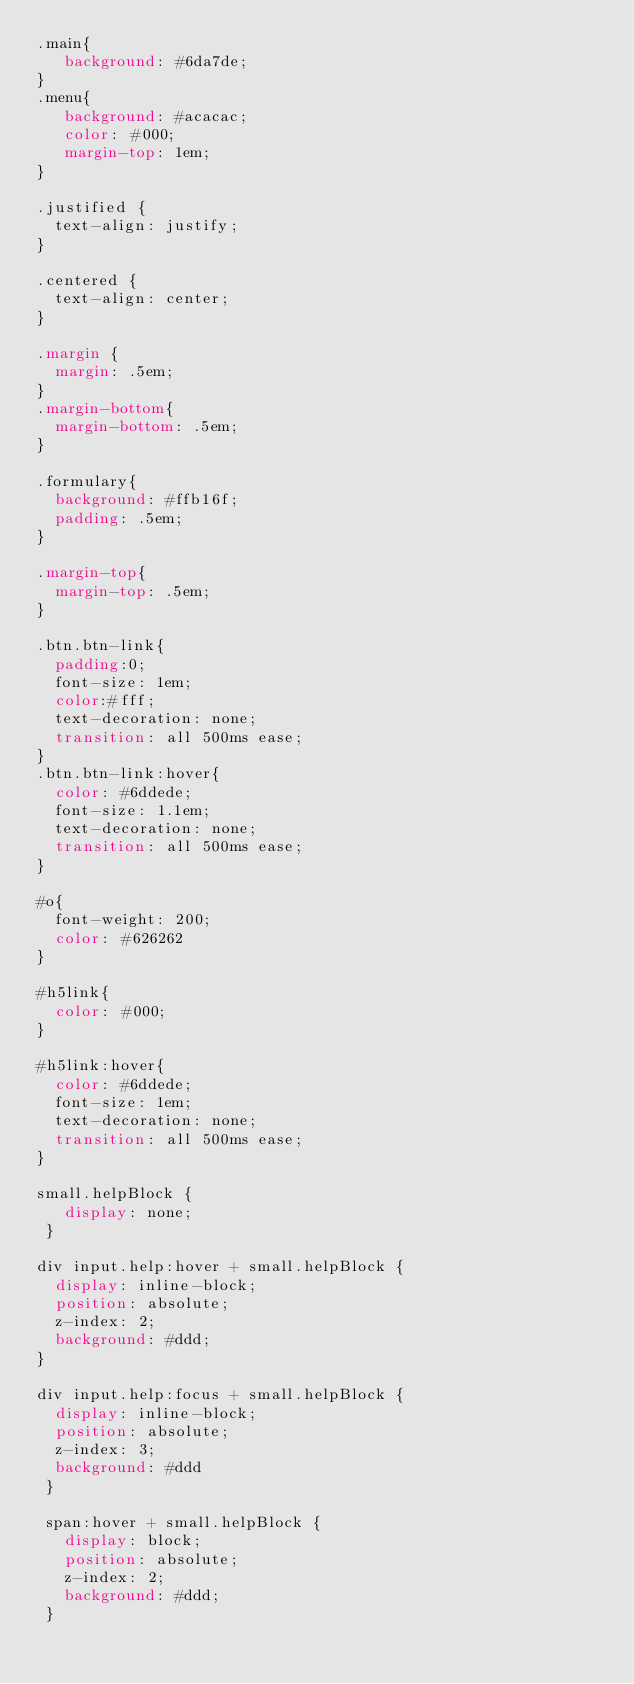<code> <loc_0><loc_0><loc_500><loc_500><_CSS_>.main{
   background: #6da7de;
}
.menu{
   background: #acacac;
   color: #000;
   margin-top: 1em;
}

.justified {
  text-align: justify;
}

.centered {
  text-align: center;
}

.margin {
  margin: .5em;
}
.margin-bottom{
  margin-bottom: .5em;
}

.formulary{
  background: #ffb16f;
  padding: .5em;
}

.margin-top{
  margin-top: .5em;
}

.btn.btn-link{
  padding:0;
  font-size: 1em;
  color:#fff;
  text-decoration: none;
  transition: all 500ms ease;
}
.btn.btn-link:hover{
  color: #6ddede;
  font-size: 1.1em;
  text-decoration: none;
  transition: all 500ms ease;
}

#o{
  font-weight: 200;
  color: #626262
}

#h5link{
  color: #000;
}

#h5link:hover{
  color: #6ddede;
  font-size: 1em;
  text-decoration: none;
  transition: all 500ms ease;
}

small.helpBlock {
   display: none;
 }

div input.help:hover + small.helpBlock {
  display: inline-block;
  position: absolute;
  z-index: 2;
  background: #ddd;
}

div input.help:focus + small.helpBlock {
  display: inline-block;
  position: absolute;
  z-index: 3;
  background: #ddd
 }

 span:hover + small.helpBlock {
   display: block;
   position: absolute;
   z-index: 2;
   background: #ddd;
 }
</code> 